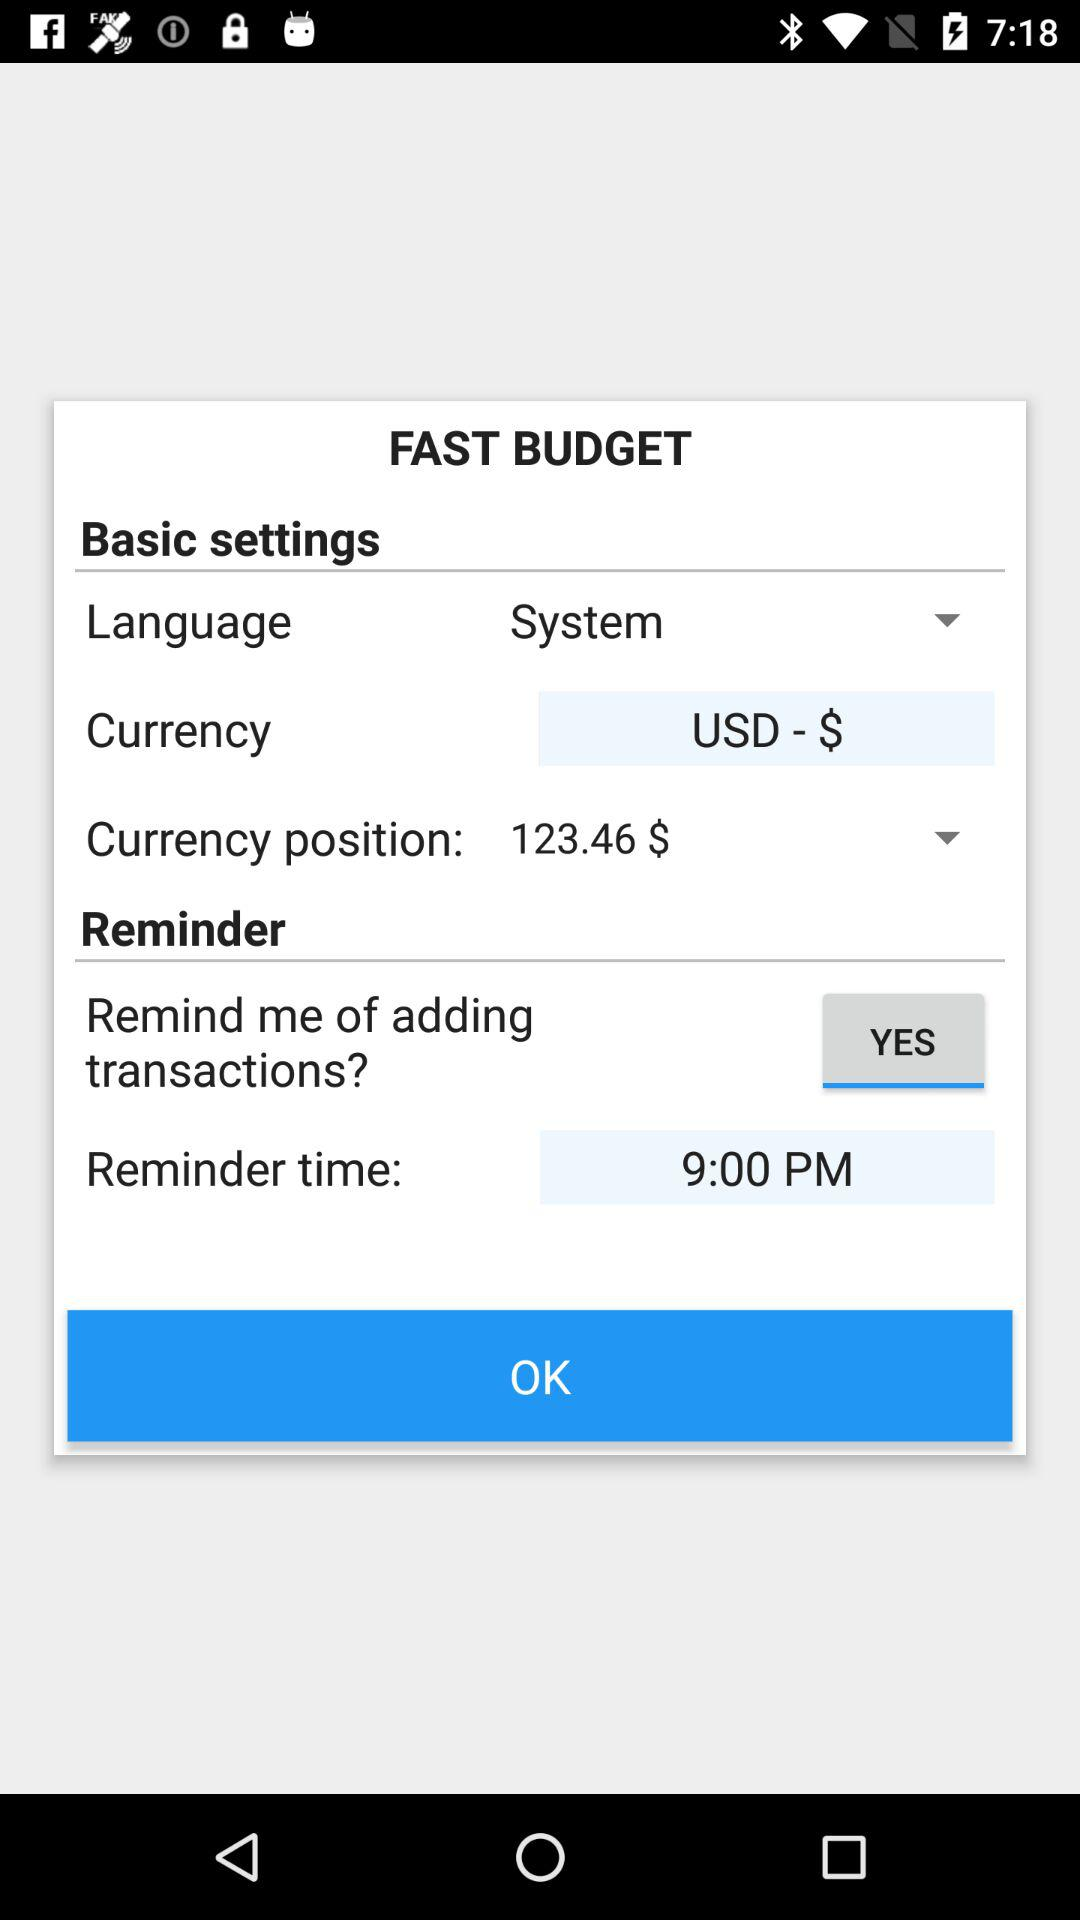What is the reminder time? The reminder time is 9:00 PM. 